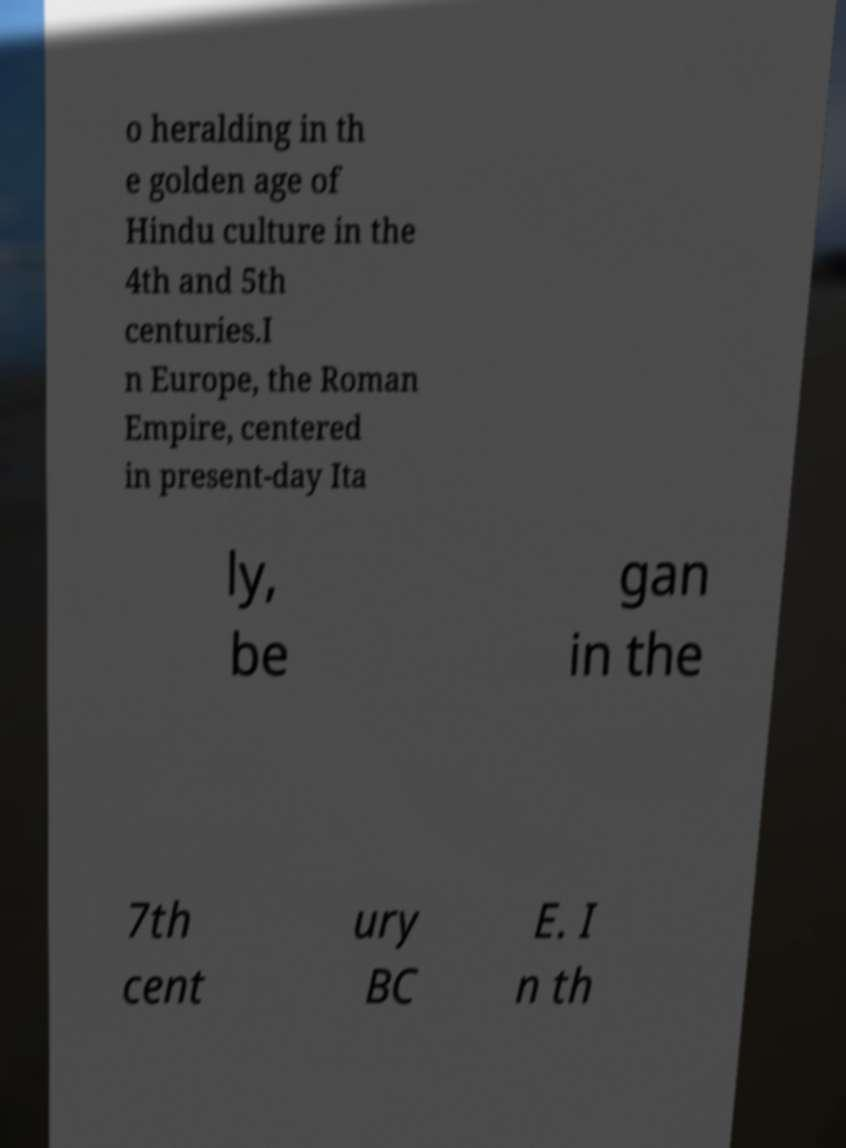Could you assist in decoding the text presented in this image and type it out clearly? o heralding in th e golden age of Hindu culture in the 4th and 5th centuries.I n Europe, the Roman Empire, centered in present-day Ita ly, be gan in the 7th cent ury BC E. I n th 